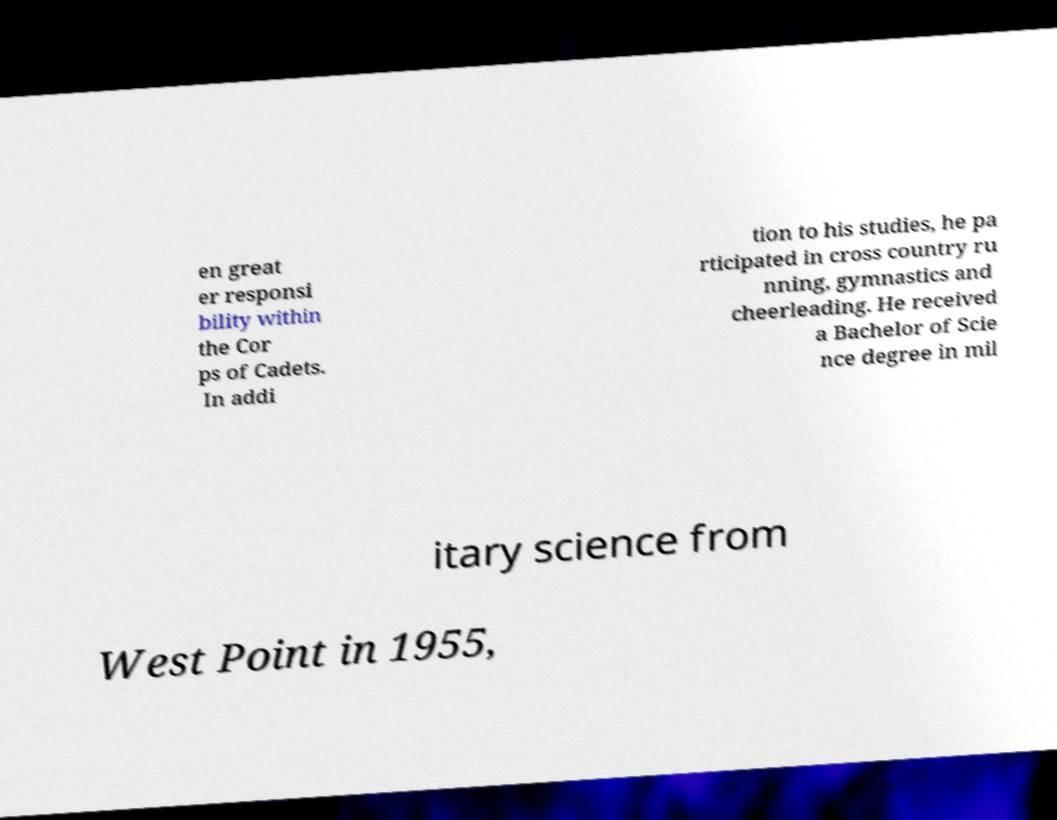I need the written content from this picture converted into text. Can you do that? en great er responsi bility within the Cor ps of Cadets. In addi tion to his studies, he pa rticipated in cross country ru nning, gymnastics and cheerleading. He received a Bachelor of Scie nce degree in mil itary science from West Point in 1955, 